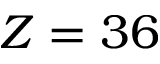Convert formula to latex. <formula><loc_0><loc_0><loc_500><loc_500>Z = 3 6</formula> 